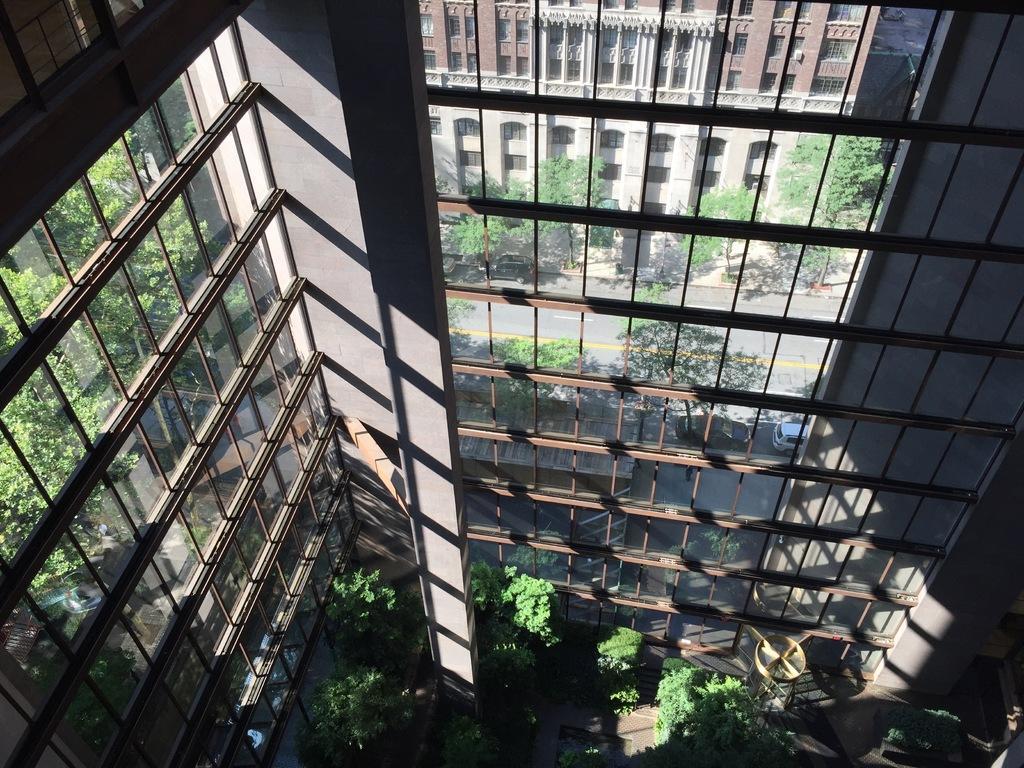Please provide a concise description of this image. At the bottom of the picture, we see the trees and an object. In this picture, we see a building which has the glass windows, from which we can see the trees, buildings and the cars. 